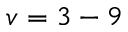Convert formula to latex. <formula><loc_0><loc_0><loc_500><loc_500>v = 3 - 9</formula> 